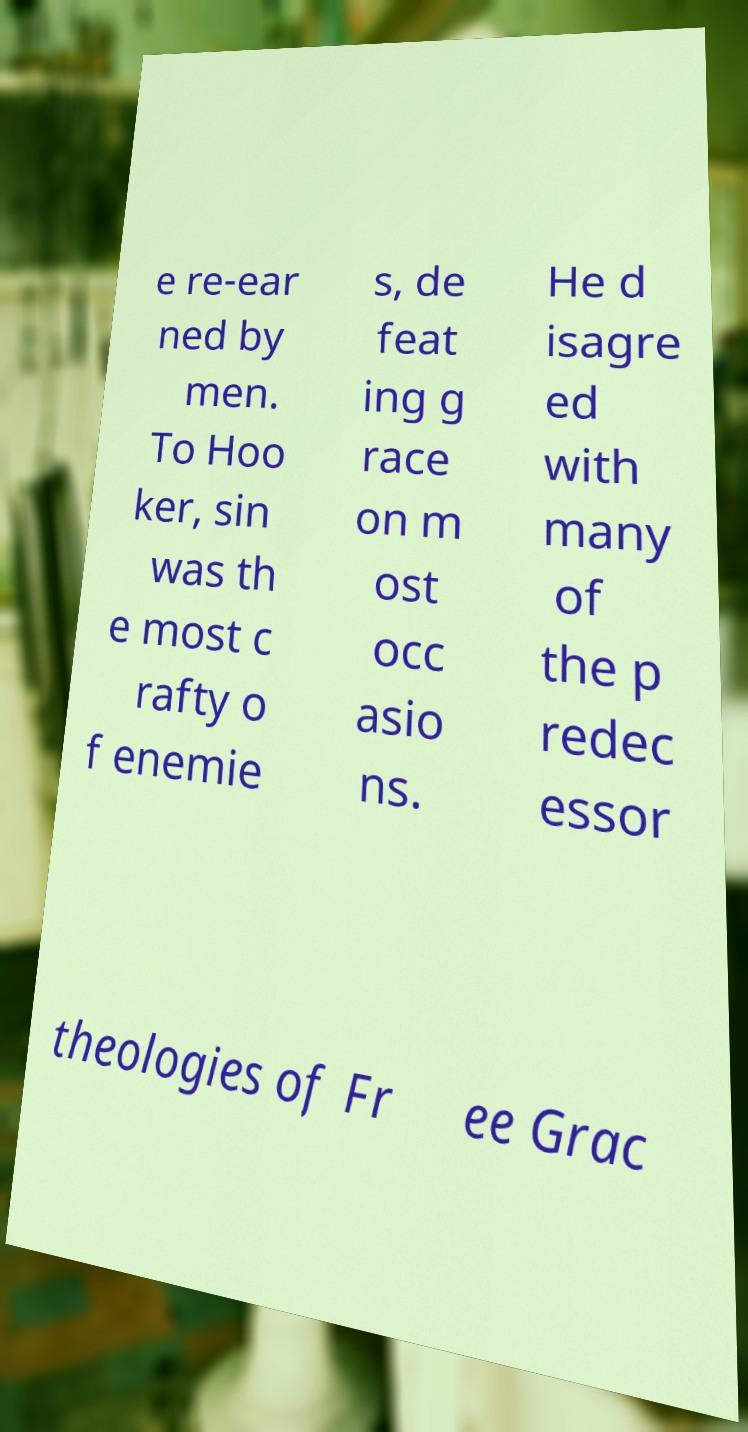For documentation purposes, I need the text within this image transcribed. Could you provide that? e re-ear ned by men. To Hoo ker, sin was th e most c rafty o f enemie s, de feat ing g race on m ost occ asio ns. He d isagre ed with many of the p redec essor theologies of Fr ee Grac 